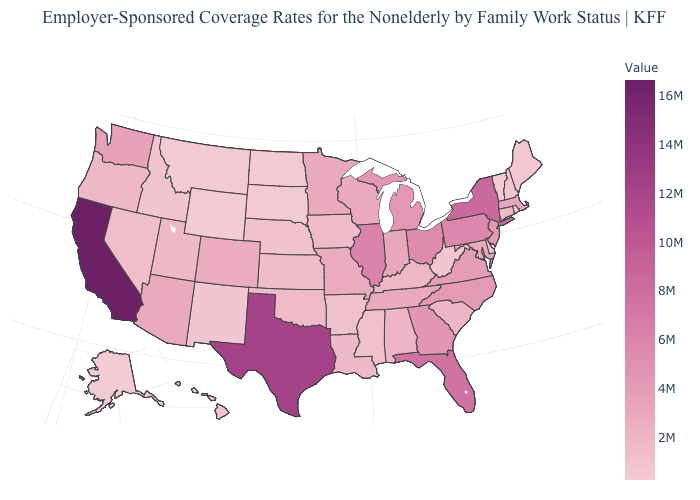Among the states that border New Jersey , does Delaware have the highest value?
Write a very short answer. No. Does Vermont have the lowest value in the USA?
Quick response, please. Yes. Does Vermont have the lowest value in the USA?
Keep it brief. Yes. Is the legend a continuous bar?
Answer briefly. Yes. Does Tennessee have a lower value than Montana?
Concise answer only. No. Which states have the lowest value in the Northeast?
Answer briefly. Vermont. Does Idaho have the lowest value in the USA?
Give a very brief answer. No. Does Louisiana have the highest value in the USA?
Short answer required. No. 